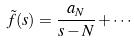Convert formula to latex. <formula><loc_0><loc_0><loc_500><loc_500>\tilde { f } ( s ) = \frac { a _ { N } } { s - N } + \cdot \cdot \cdot</formula> 